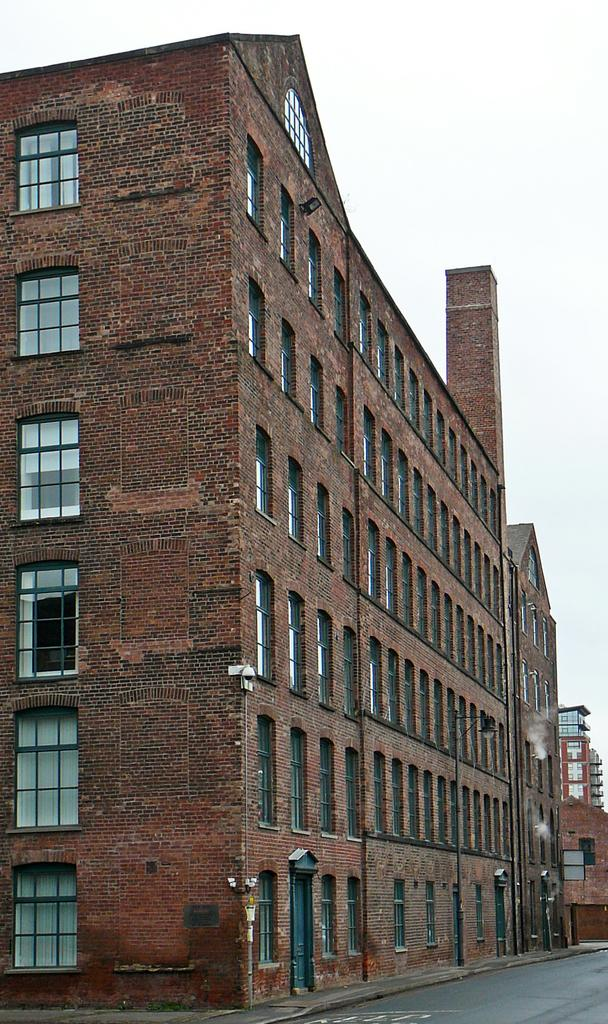What type of structures are present in the image? There are buildings in the image. What features can be seen on the buildings? The buildings have windows and doors. What additional elements are visible in the image? There are light posts visible in the image. What color is the governor's scarf in the image? There is no governor or scarf present in the image. How many gates are visible in the image? There are no gates visible in the image. 